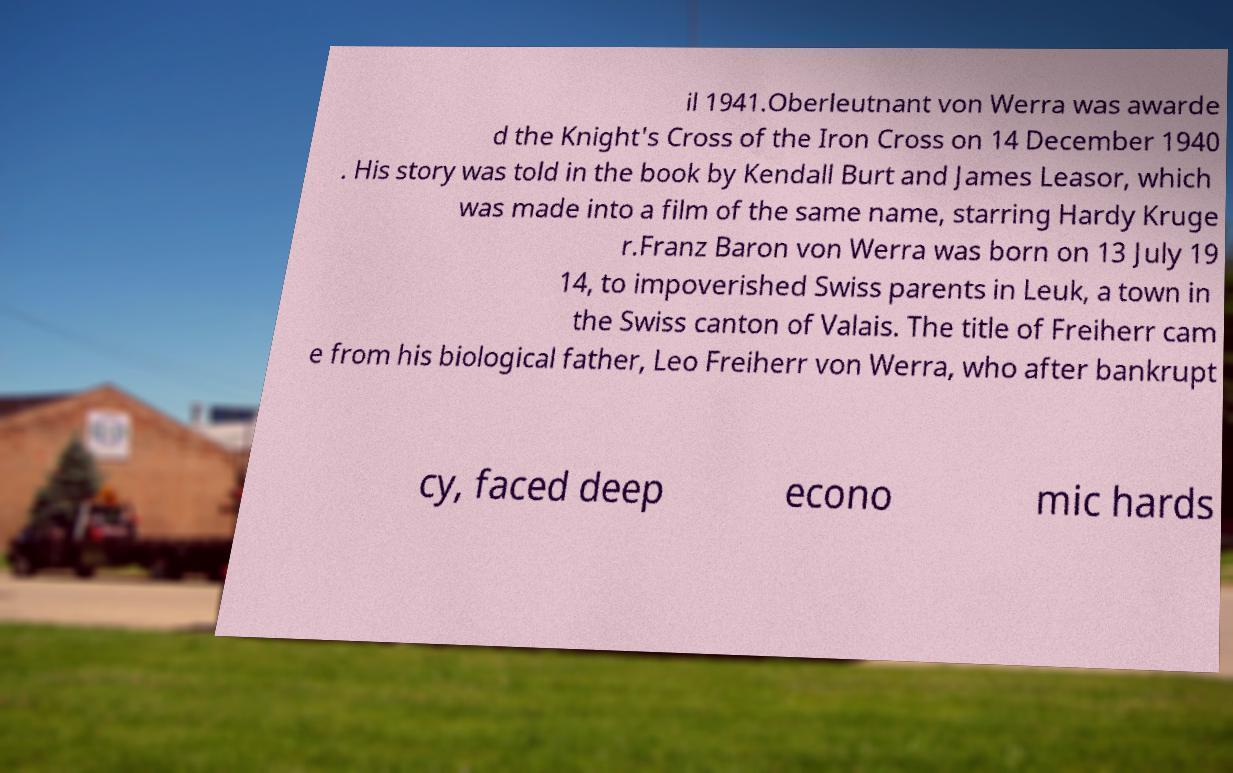I need the written content from this picture converted into text. Can you do that? il 1941.Oberleutnant von Werra was awarde d the Knight's Cross of the Iron Cross on 14 December 1940 . His story was told in the book by Kendall Burt and James Leasor, which was made into a film of the same name, starring Hardy Kruge r.Franz Baron von Werra was born on 13 July 19 14, to impoverished Swiss parents in Leuk, a town in the Swiss canton of Valais. The title of Freiherr cam e from his biological father, Leo Freiherr von Werra, who after bankrupt cy, faced deep econo mic hards 